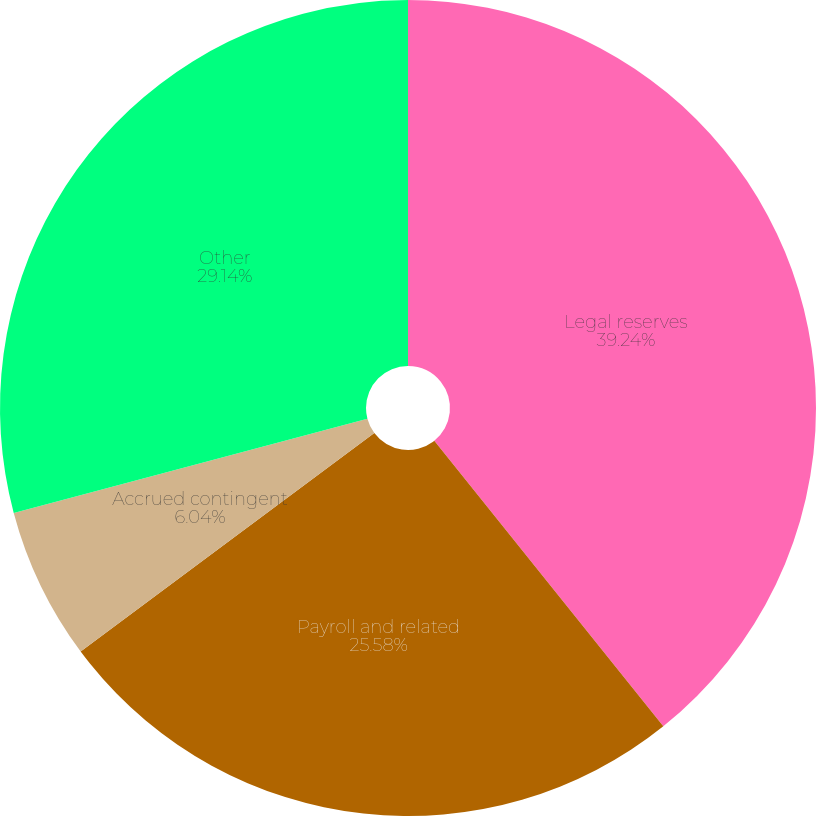<chart> <loc_0><loc_0><loc_500><loc_500><pie_chart><fcel>Legal reserves<fcel>Payroll and related<fcel>Accrued contingent<fcel>Other<nl><fcel>39.24%<fcel>25.58%<fcel>6.04%<fcel>29.14%<nl></chart> 